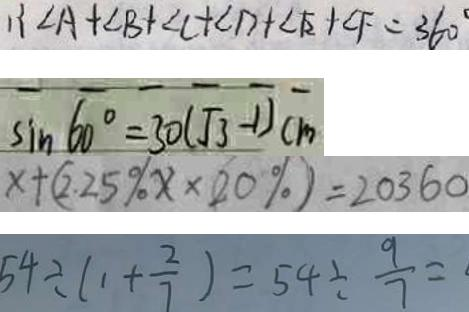<formula> <loc_0><loc_0><loc_500><loc_500>\therefore \angle A + \angle B + \angle C + \angle D + \angle E + \angle F = 3 6 0 ^ { \circ } 
 \sin 6 0 ^ { \circ } = 3 0 ( \sqrt { 3 } - 1 ) c m 
 x + ( 2 . 2 5 \% x \times 2 0 \% ) = 2 0 3 6 0 
 5 4 \div ( 1 + \frac { 2 } { 7 } ) = 5 4 \div \frac { 9 } { 7 } =</formula> 